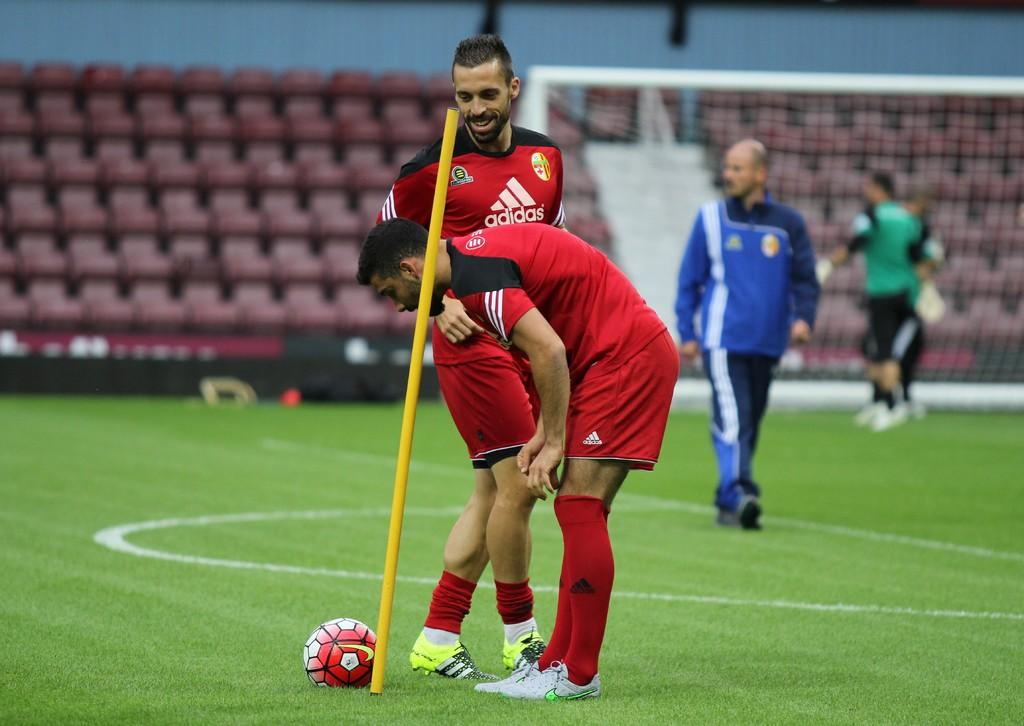Provide a one-sentence caption for the provided image. Male soccer players wearing red adidas jerseys and shorts. 